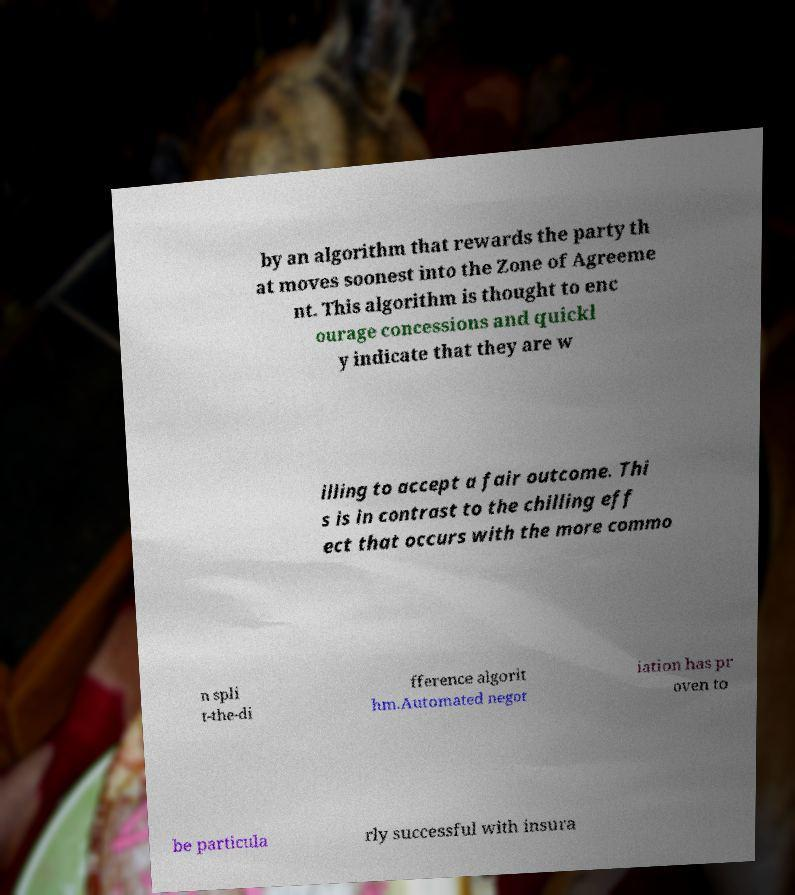Could you extract and type out the text from this image? by an algorithm that rewards the party th at moves soonest into the Zone of Agreeme nt. This algorithm is thought to enc ourage concessions and quickl y indicate that they are w illing to accept a fair outcome. Thi s is in contrast to the chilling eff ect that occurs with the more commo n spli t-the-di fference algorit hm.Automated negot iation has pr oven to be particula rly successful with insura 